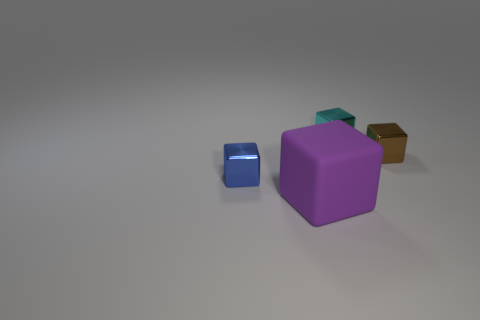How do the blocks appear in terms of lighting and texture? The image shows the blocks with a matte finish, each illuminated uniformly with soft lighting that produces gentle shadows on the ground, indicating a diffused light source. Does this lighting reveal anything about the shape of the blocks? Yes, the soft shadows help accentuate the blocks' shapes, making it clear that they are all perfect cubes with sharp edges and flat faces. 